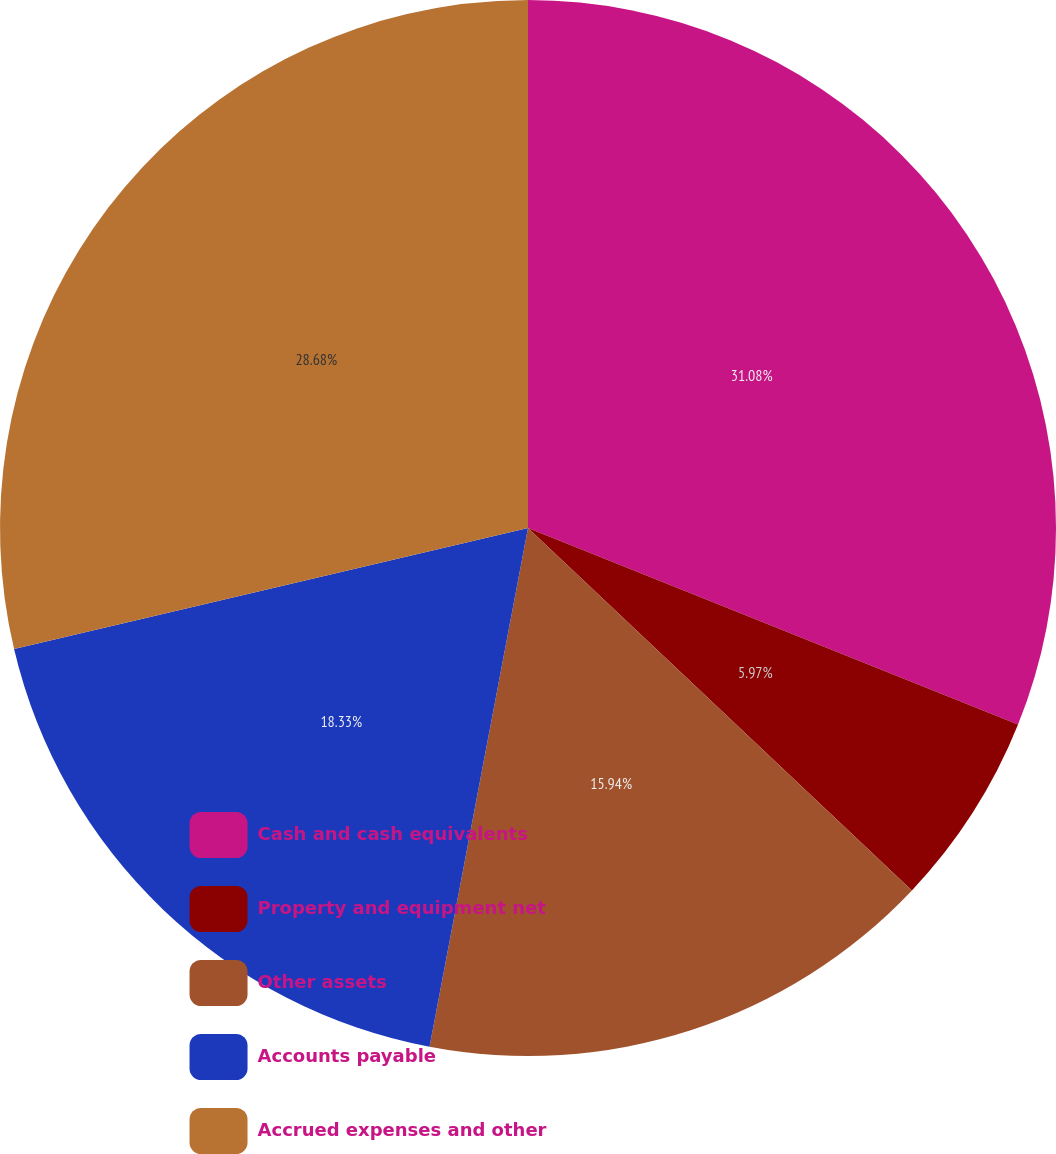Convert chart. <chart><loc_0><loc_0><loc_500><loc_500><pie_chart><fcel>Cash and cash equivalents<fcel>Property and equipment net<fcel>Other assets<fcel>Accounts payable<fcel>Accrued expenses and other<nl><fcel>31.07%<fcel>5.97%<fcel>15.94%<fcel>18.33%<fcel>28.68%<nl></chart> 